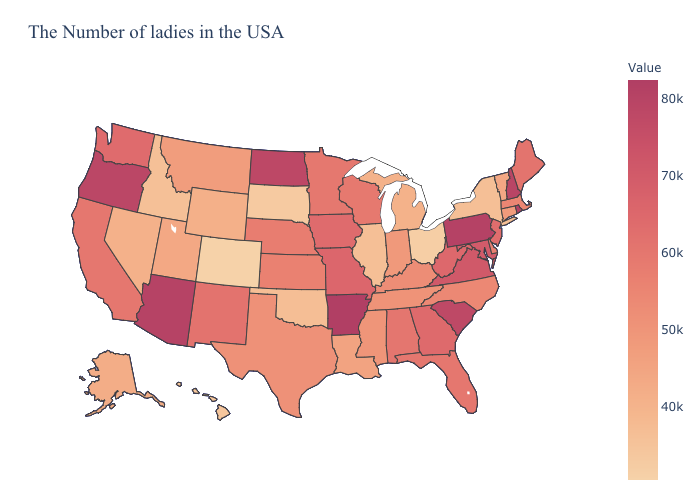Which states have the lowest value in the South?
Be succinct. Oklahoma. Does Arkansas have the highest value in the USA?
Be succinct. Yes. Is the legend a continuous bar?
Be succinct. Yes. 